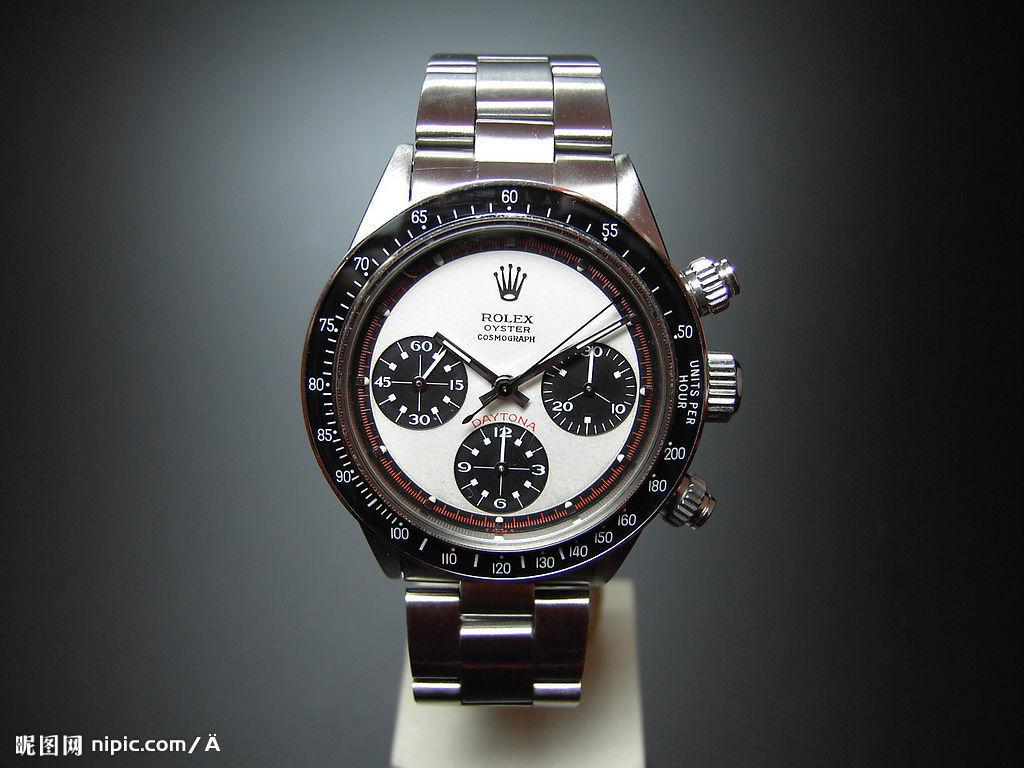<image>
Create a compact narrative representing the image presented. A silver Rolex oyster watch with a white face is displayed on a stand. 